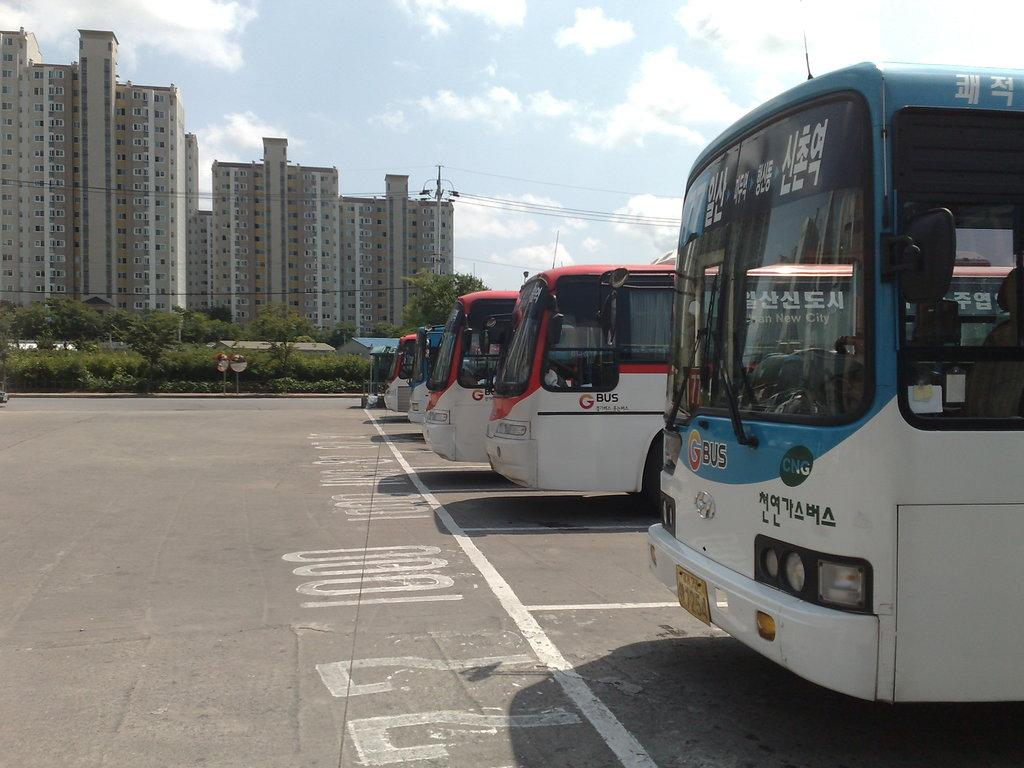<image>
Create a compact narrative representing the image presented. bus number 77 lined up with other buses in a row 